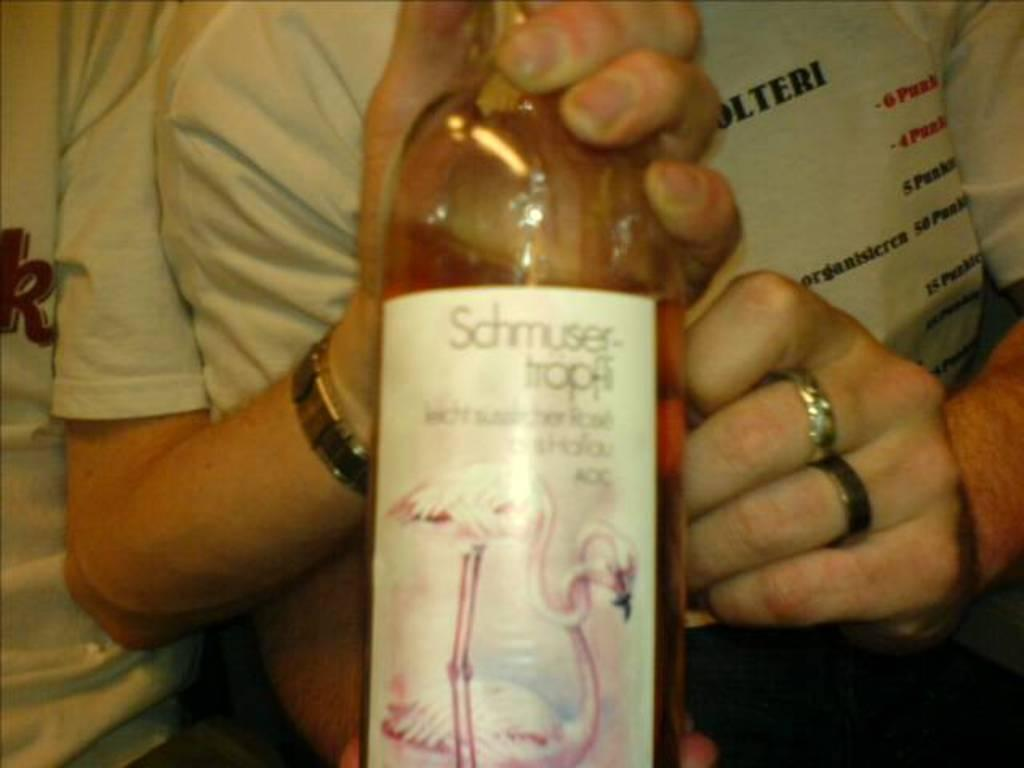<image>
Summarize the visual content of the image. the word shmuser that is on a bottle 